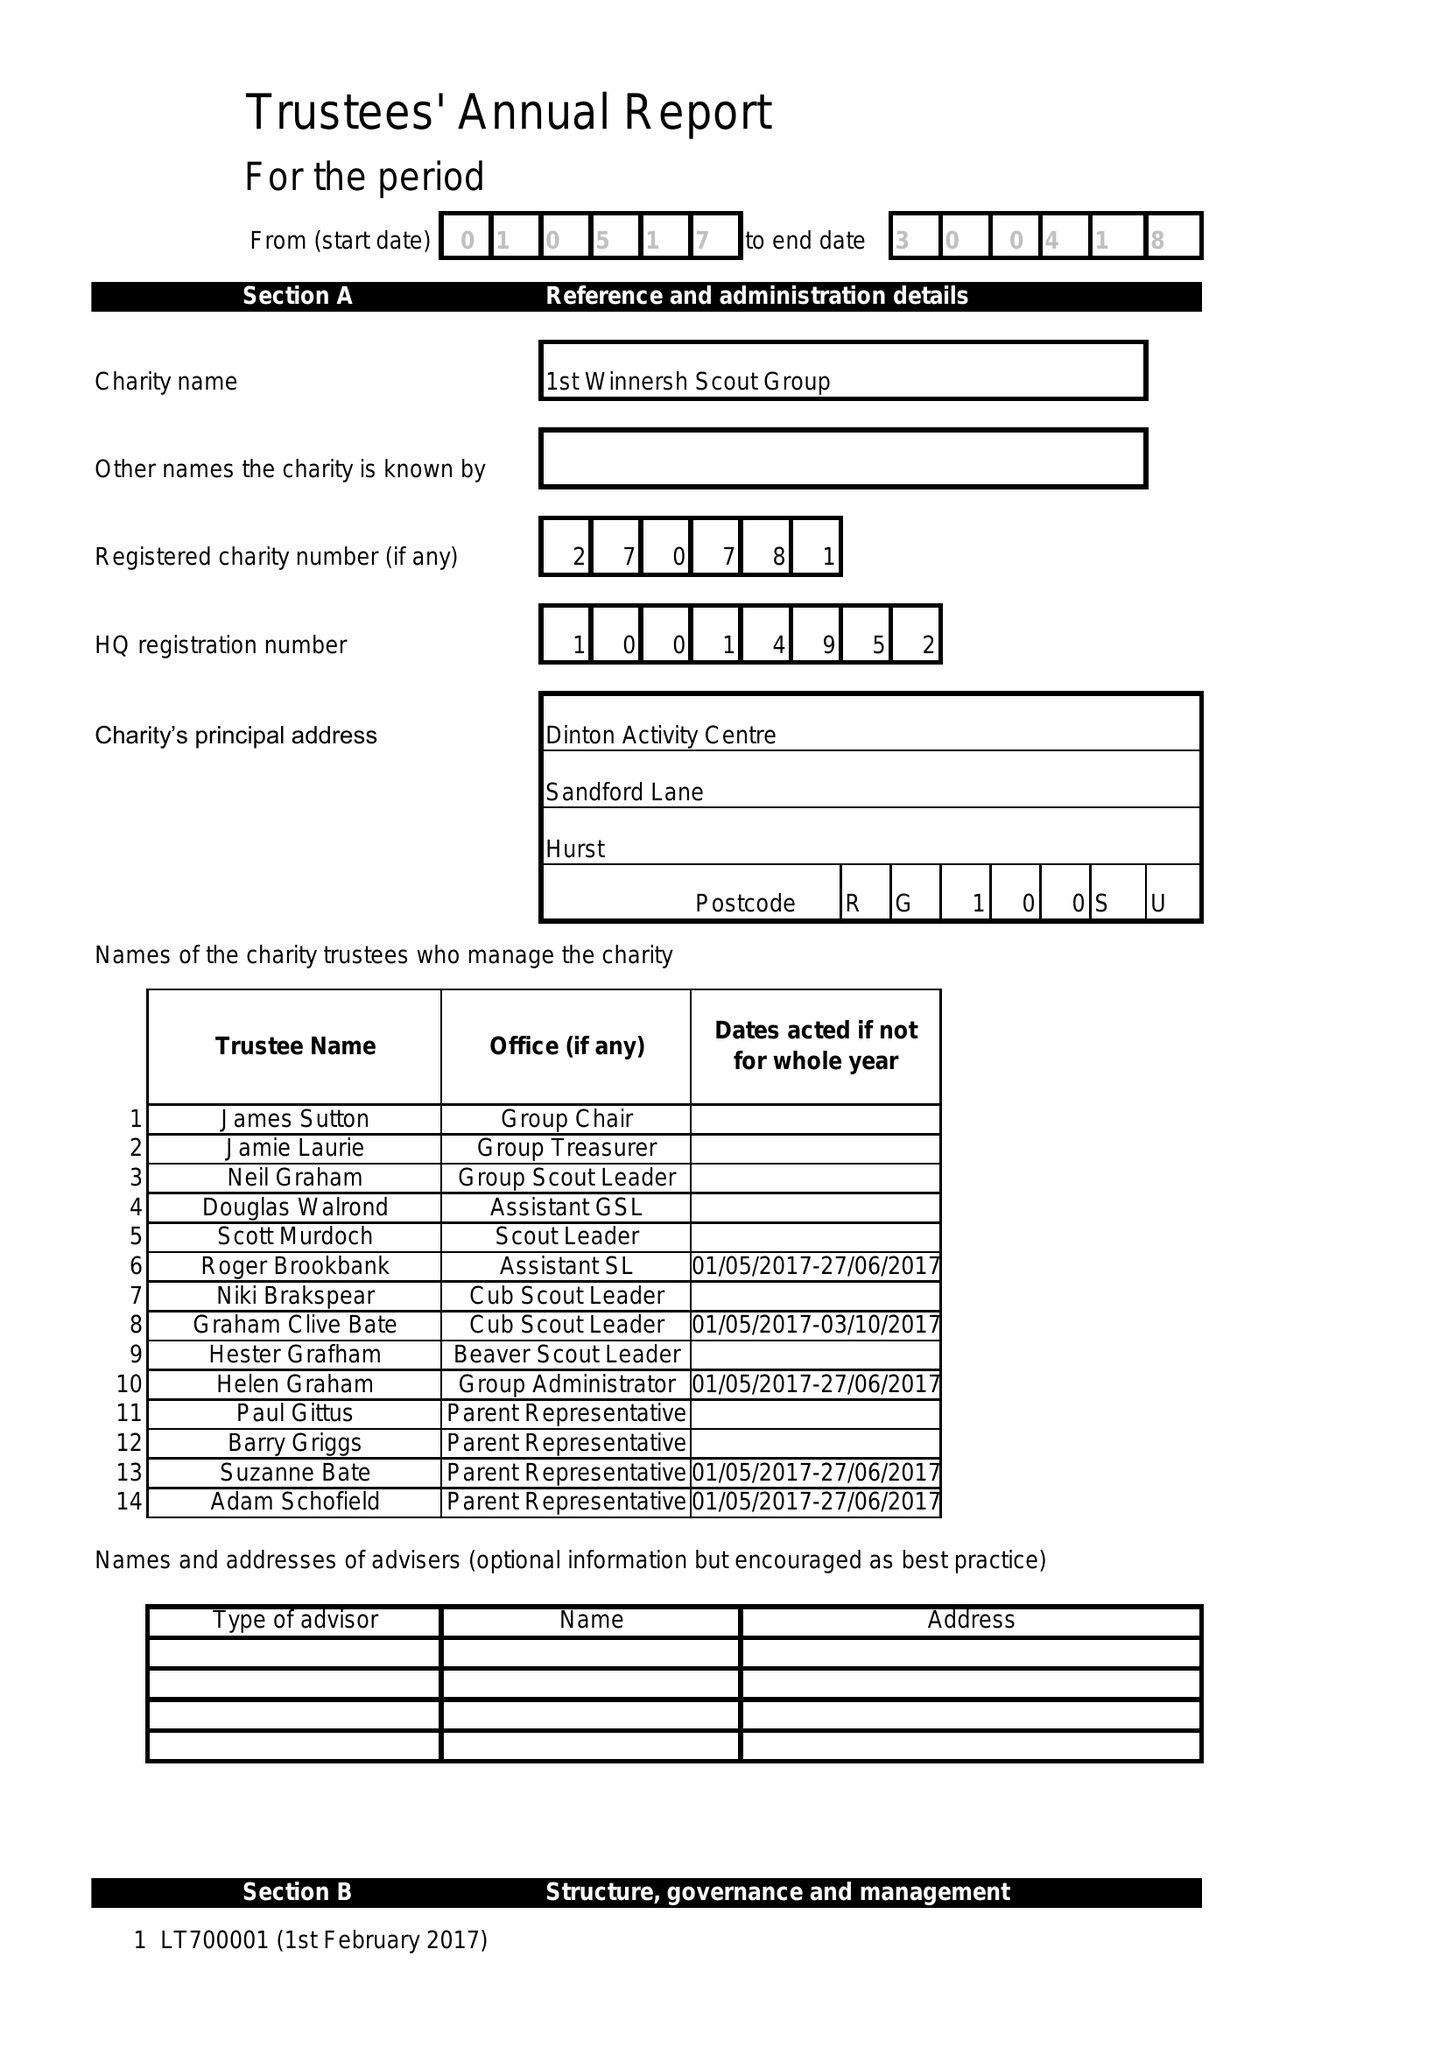What is the value for the report_date?
Answer the question using a single word or phrase. 2018-04-30 